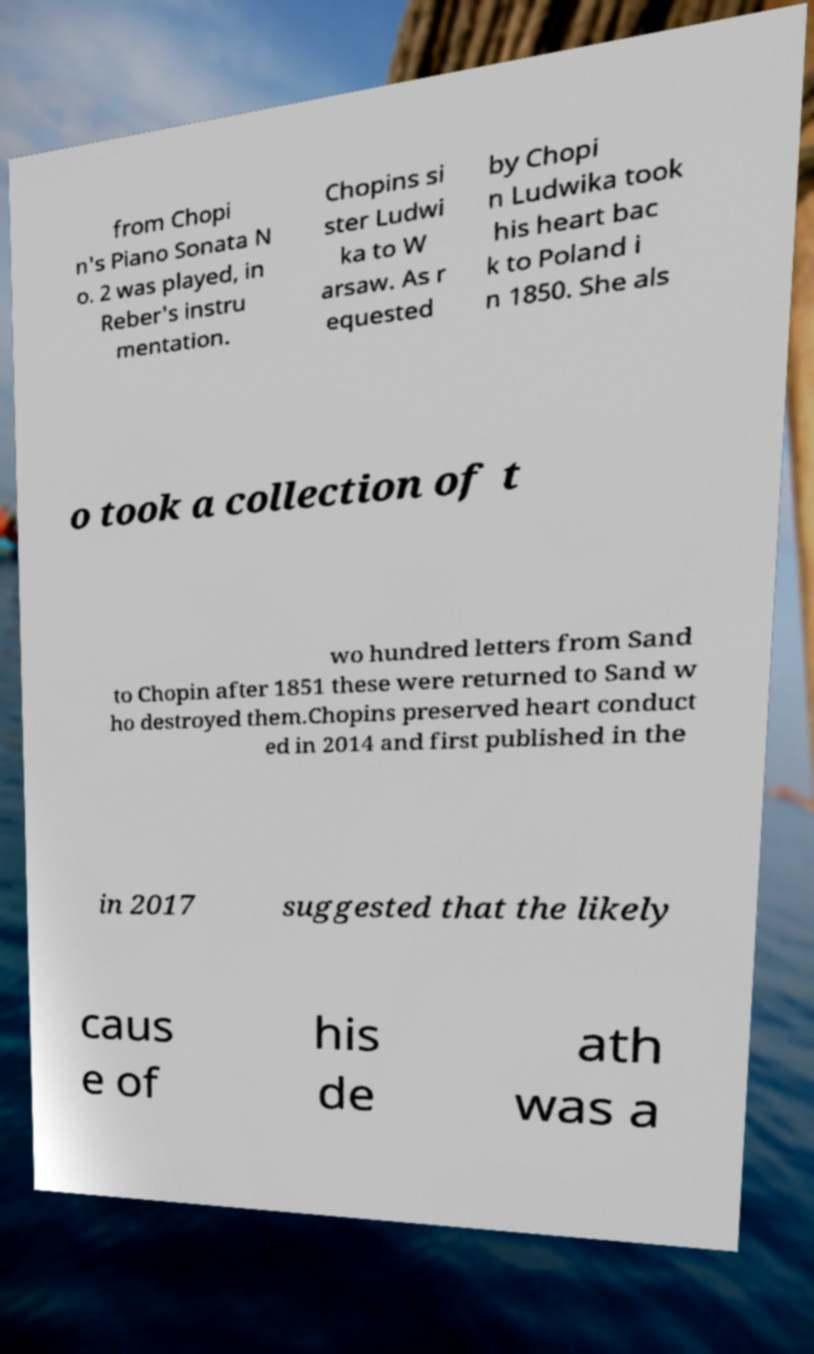For documentation purposes, I need the text within this image transcribed. Could you provide that? from Chopi n's Piano Sonata N o. 2 was played, in Reber's instru mentation. Chopins si ster Ludwi ka to W arsaw. As r equested by Chopi n Ludwika took his heart bac k to Poland i n 1850. She als o took a collection of t wo hundred letters from Sand to Chopin after 1851 these were returned to Sand w ho destroyed them.Chopins preserved heart conduct ed in 2014 and first published in the in 2017 suggested that the likely caus e of his de ath was a 